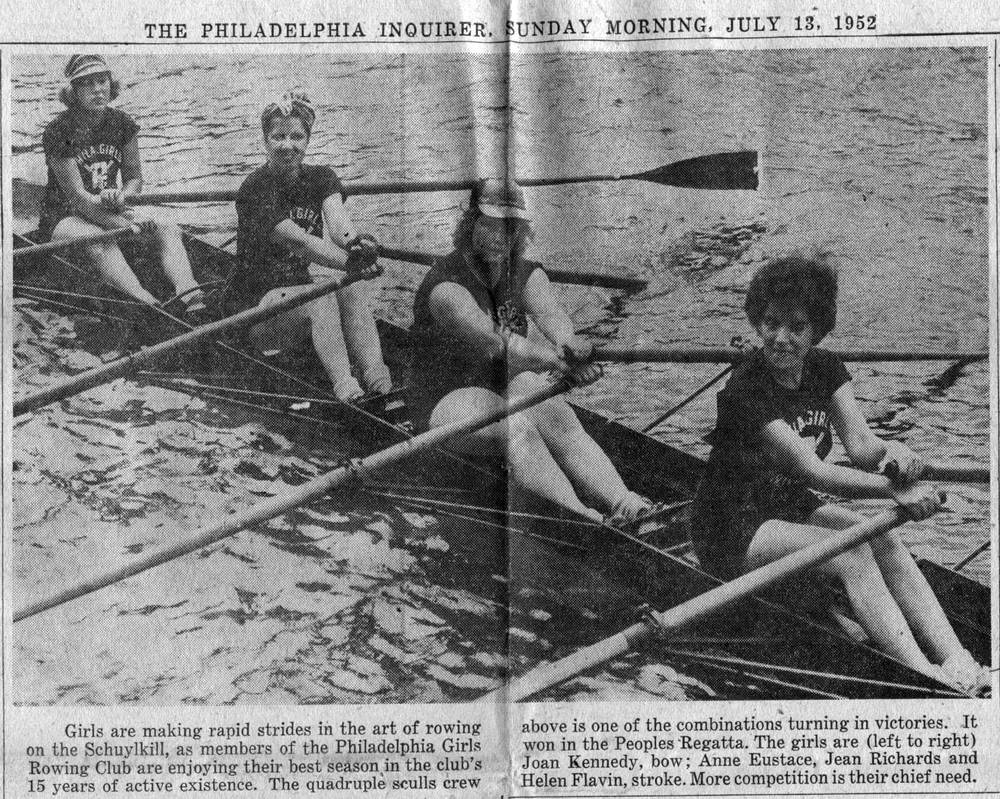Considering the equipment visible in the photo, what can be inferred about the technological advancements in rowing at the time? The equipment, such as the wooden oars and the classical shell design, reflects the technological limitations of the era. Modern advancements might include carbon fiber oars and advanced boat hull designs for greater efficiency and speed, yet the skill and determination of these rowers shine through, showcasing the sport's essence irrespective of time. 